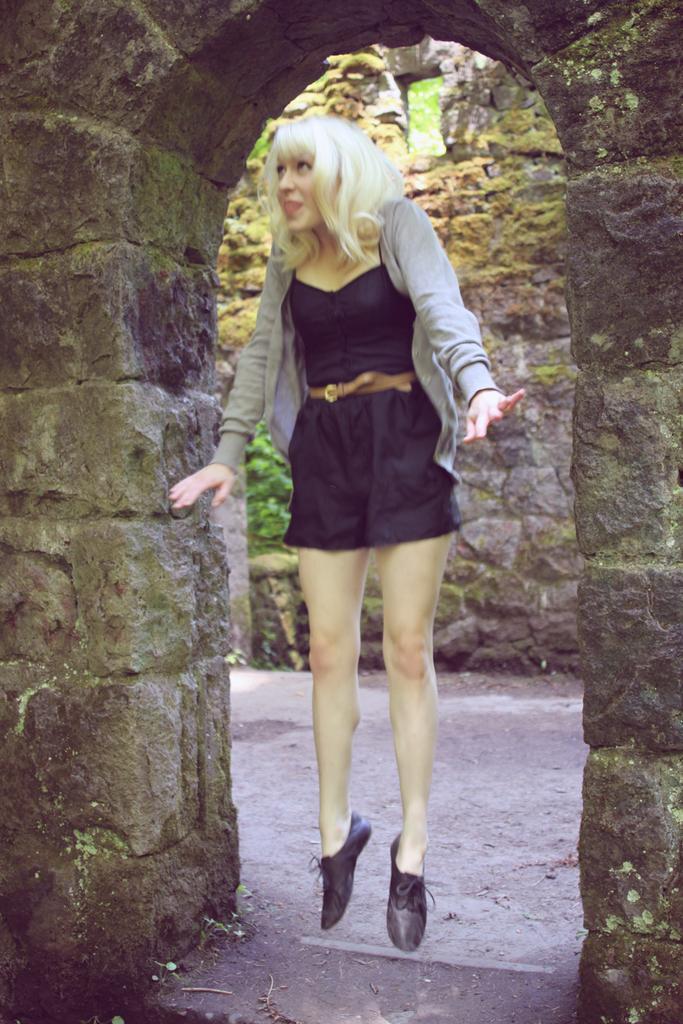Please provide a concise description of this image. In the center of the picture we can see a woman wearing blue color dress and jumping in the air. In the background we can see the wall and arch and we can see the window and the ground. 